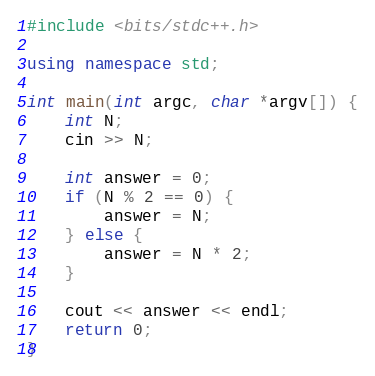Convert code to text. <code><loc_0><loc_0><loc_500><loc_500><_C++_>#include <bits/stdc++.h>

using namespace std;

int main(int argc, char *argv[]) {
	int N;
	cin >> N;

	int answer = 0;
	if (N % 2 == 0) {
		answer = N;
	} else {
		answer = N * 2;
	}

	cout << answer << endl;
	return 0;
}
</code> 